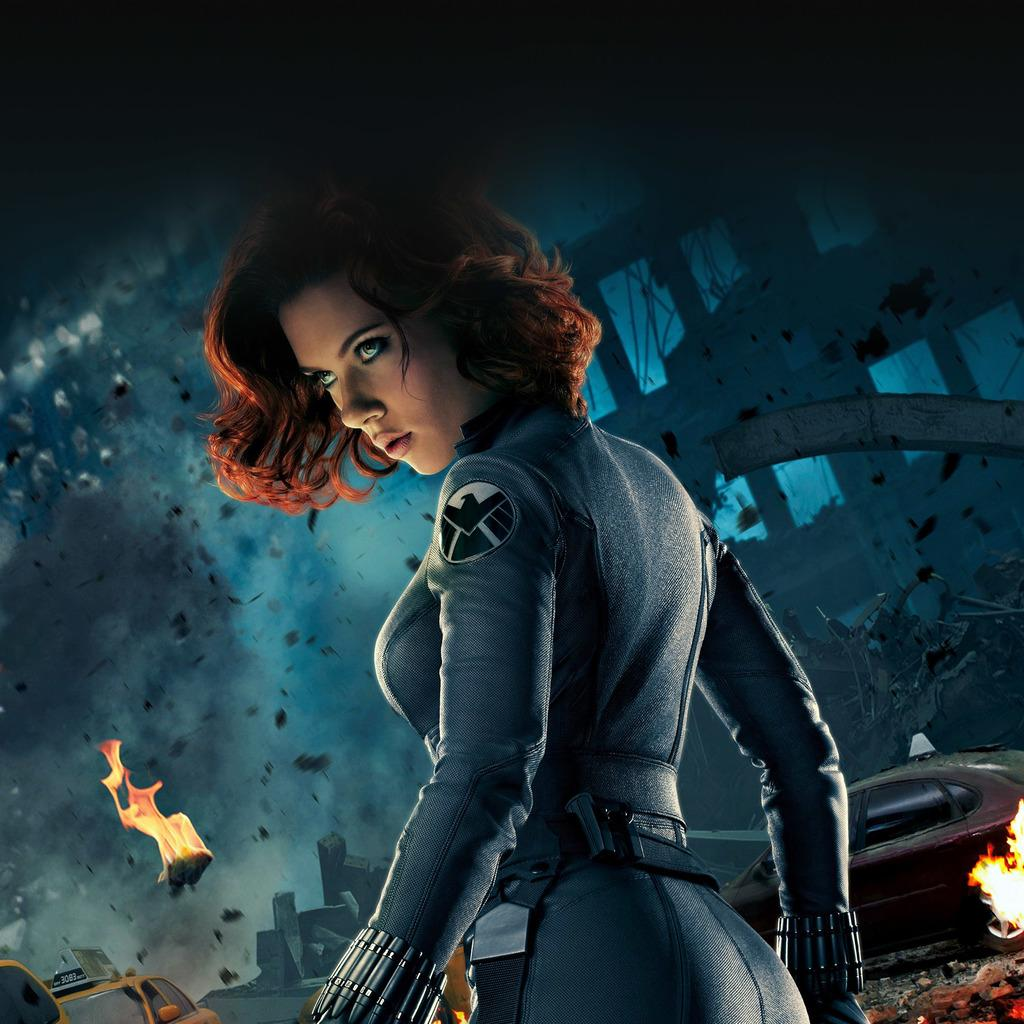What type of picture is in the image? The image contains an animated picture. Can you describe the scene in the animated picture? There is a woman standing in the animated picture, along with fire and smoke. What is the nature of the fire in the animated picture? The fire is present in the animated picture, but the specific details of the fire are not mentioned in the facts. What is the purpose of the apple in the animated picture? There is no apple present in the image or the animated picture. 